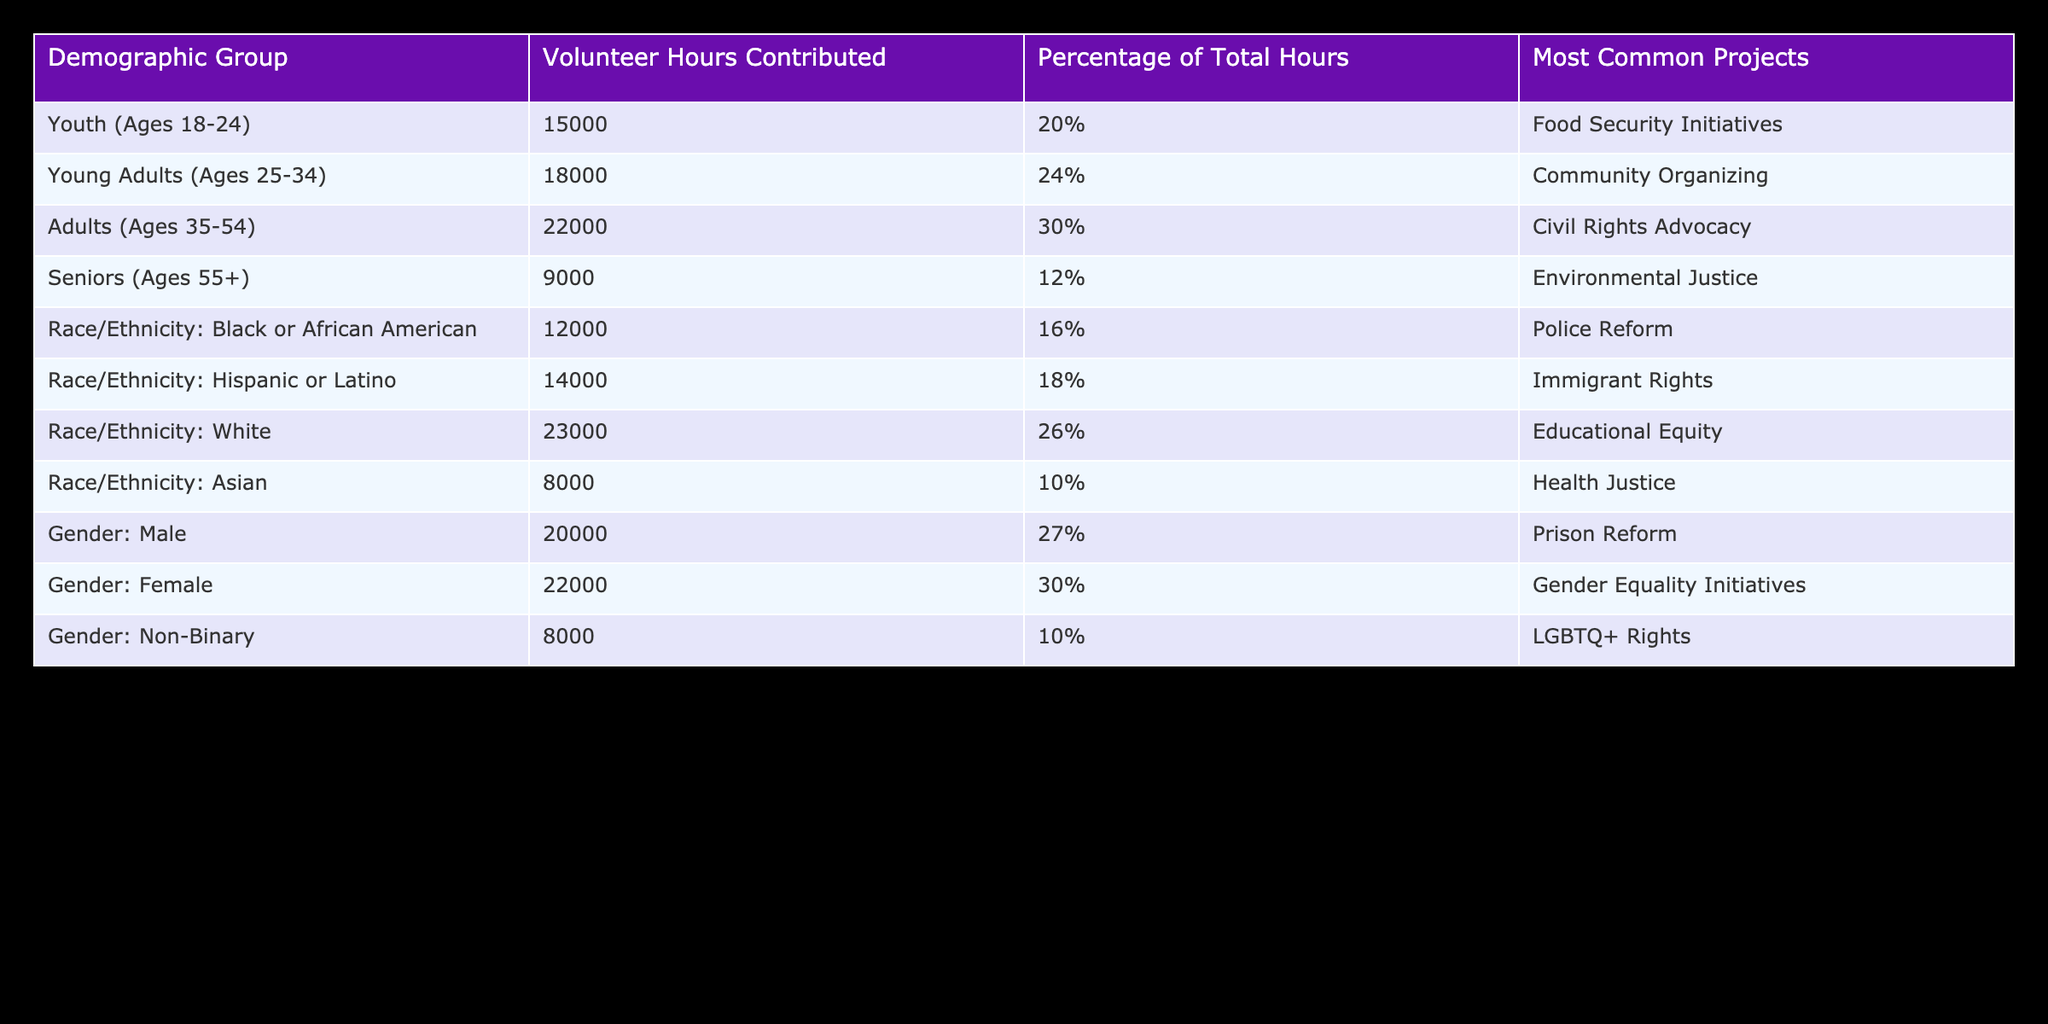What demographic group contributed the most volunteer hours? The row for "Adults (Ages 35-54)" shows the highest volunteer hours contributed, which is 22000 hours.
Answer: Adults (Ages 35-54) Which demographic group contributed the least volunteer hours? The row for "Asian" shows the lowest volunteer hours contributed, which is 8000 hours.
Answer: Asian What percentage of total volunteer hours did Young Adults (Ages 25-34) contribute? The percentage column indicates that Young Adults contributed 24% of the total hours.
Answer: 24% Is the most common project for Seniors related to environmental justice? The table states that the most common project for Seniors (Ages 55+) is Environmental Justice, confirming the statement is true.
Answer: Yes What is the total number of volunteer hours contributed by all demographic groups combined? Adding the volunteer hours: 15000 + 18000 + 22000 + 9000 + 12000 + 14000 + 23000 + 8000 + 20000 + 22000 + 8000 = 120000 hours total.
Answer: 120000 Which demographic group has the highest percentage of total volunteer hours and what is that percentage? From the table, "Adults (Ages 35-54)" has the highest percentage at 30%.
Answer: Adults (Ages 35-54), 30% If we combine the volunteer hours of Non-Binary and Youth, how many hours do they contribute together? Adding the volunteer hours for Non-Binary (8000) and Youth (15000) gives us a total of 23000 hours (8000 + 15000).
Answer: 23000 Is the percentage of volunteer hours contributed by Black or African American and Hispanic or Latino communities greater than that contributed by the Youth demographic? The percentages from the table show Black or African American at 16% and Hispanic or Latino at 18%, totaling 34%. The Youth demographic percentage is 20%. Since 34% is greater than 20%, the statement is true.
Answer: Yes Which demographic group contributed more hours, Adults (Ages 35-54) or Females? The table indicates Adults contributed 22000 hours while Females contributed 22000 hours; both have equal contributions.
Answer: They contributed equally 